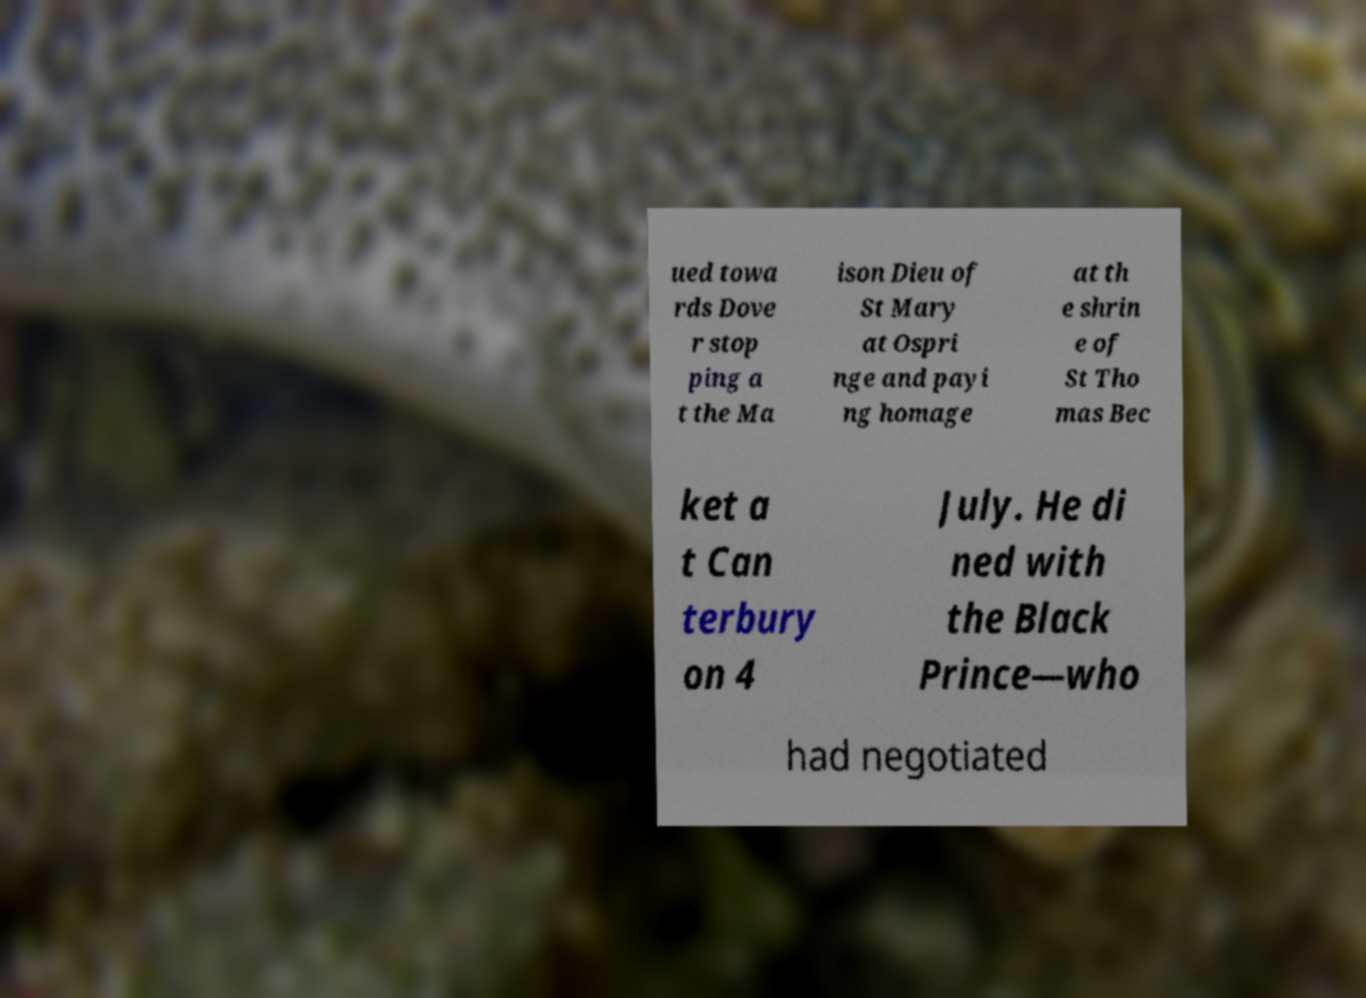Can you read and provide the text displayed in the image?This photo seems to have some interesting text. Can you extract and type it out for me? ued towa rds Dove r stop ping a t the Ma ison Dieu of St Mary at Ospri nge and payi ng homage at th e shrin e of St Tho mas Bec ket a t Can terbury on 4 July. He di ned with the Black Prince—who had negotiated 